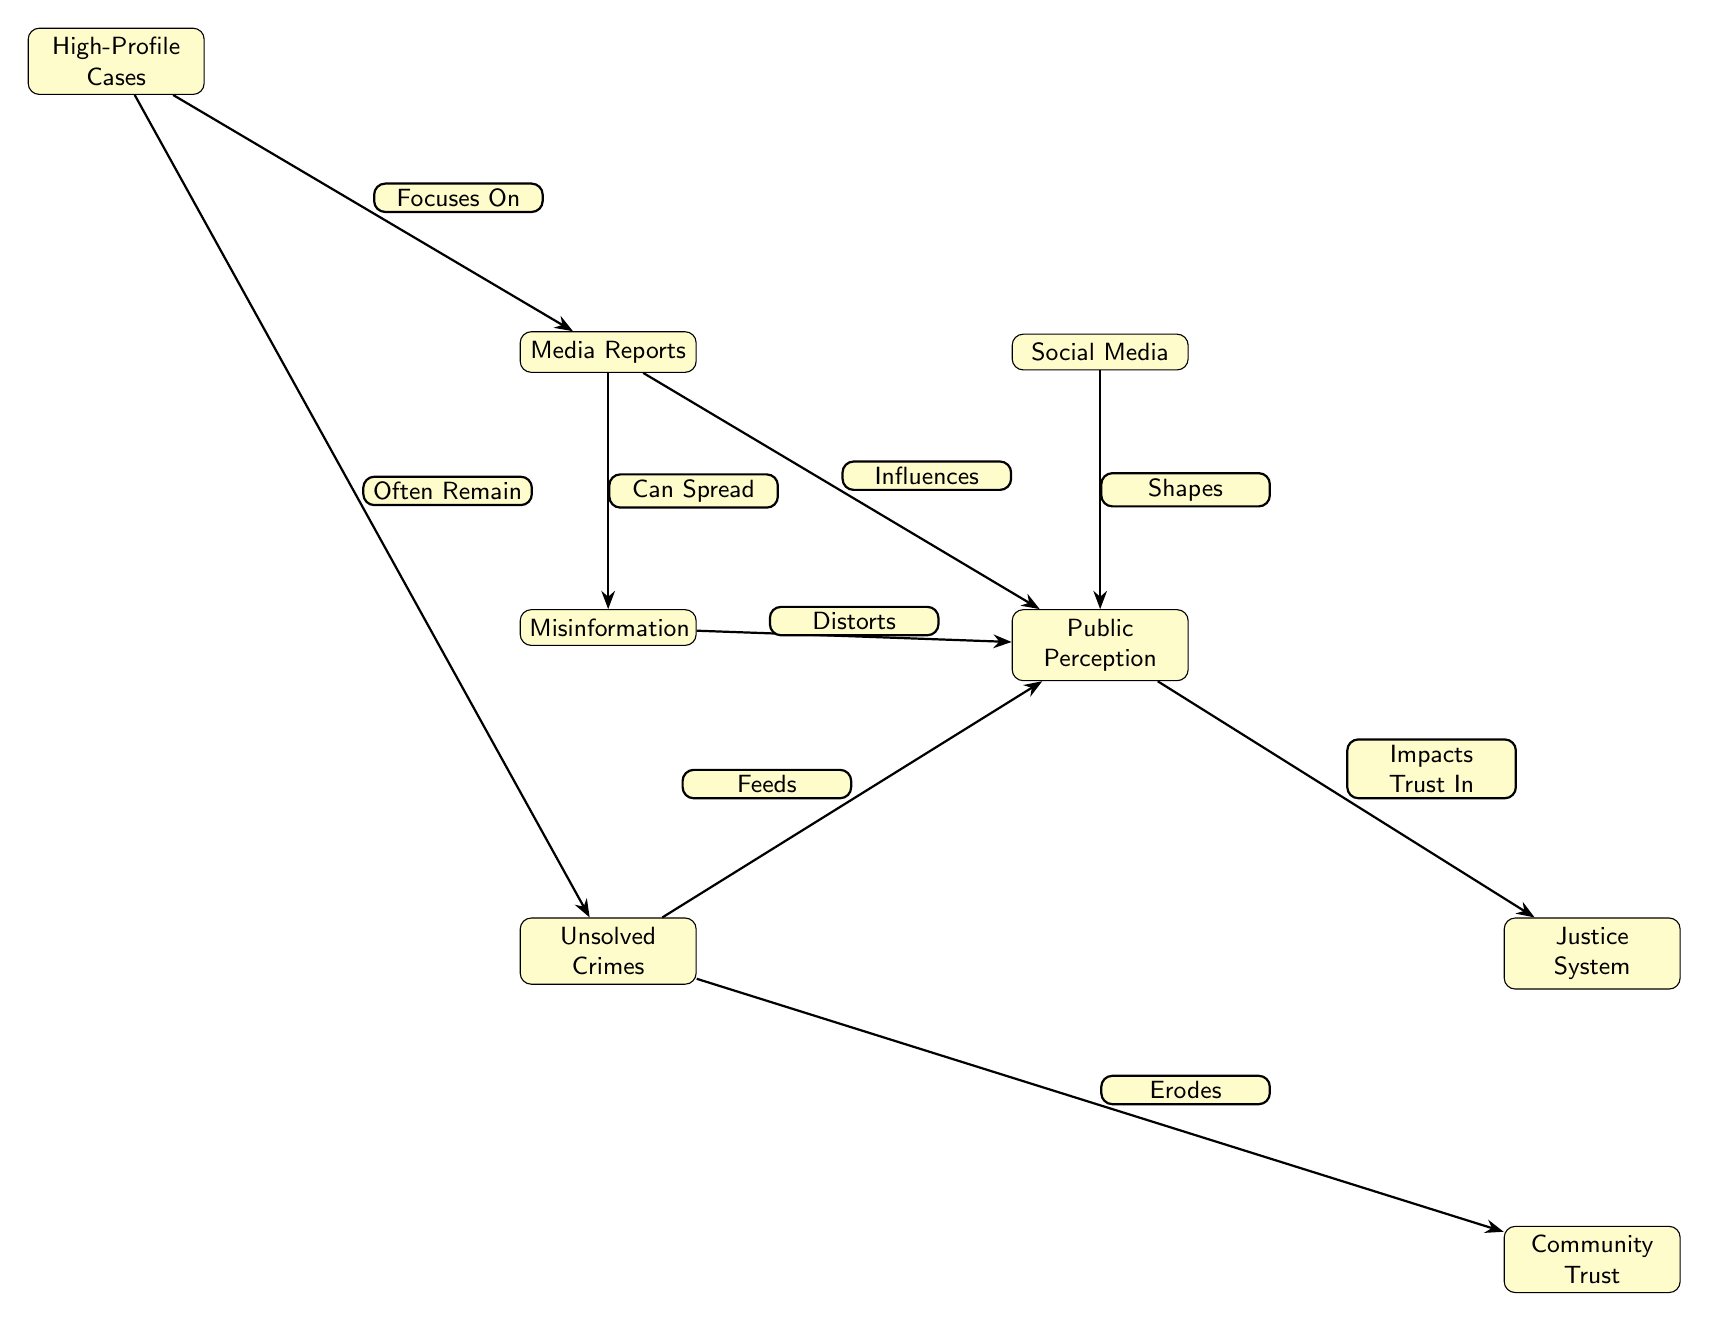What is the primary source that influences public perception? The diagram indicates that Media Reports influence public perception directly as shown by the arrow connecting these two nodes.
Answer: Media Reports How many nodes are present in the diagram? By counting the distinct entities represented in the diagram, we find there are eight nodes: Media Reports, Social Media, Public Perception, Unsolved Crimes, Justice System, High-Profile Cases, Misinformation, and Community Trust.
Answer: Eight What does social media do to public perception? According to the diagram, social media shapes public perception as indicated by the arrow leading to that node.
Answer: Shapes Which node directly impacts trust in the justice system? The arrow flows from the Public Perception node to the Justice System node, indicating that public perception impacts trust in the justice system.
Answer: Public Perception What action do high-profile cases take towards media reports? High-profile cases focus on media reports as indicated by the arrow connecting these two nodes, showcasing a direct relationship.
Answer: Focuses On How does misinformation affect public perception? The diagram shows that misinformation distorts public perception, as reflected by the directed edge from misinformation to public perception.
Answer: Distorts What is the relationship between unsolved crimes and community trust? The diagram illustrates that unsolved crimes erode community trust, demonstrated by the directed edge from the unsolved crimes node to the community trust node.
Answer: Erodes What can media reports spread? The diagram states that media reports can spread misinformation, which is illustrated by the direct edge connecting these two nodes.
Answer: Can Spread What do unsolved crimes feed into? The directed relationship from unsolved crimes to public perception indicates that unsolved crimes feed into public perception.
Answer: Feeds 